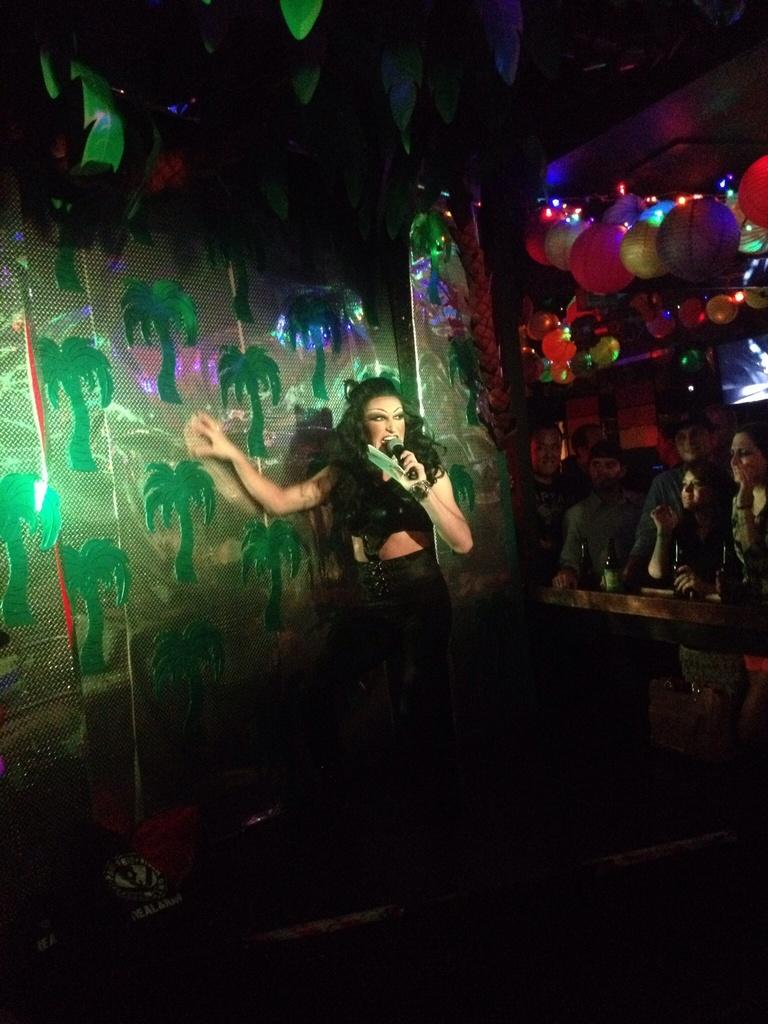What is the woman in the image holding? The woman is holding a mic and another object. Can you describe the group of people in the image? There is a group of people in the image, but their specific actions or characteristics are not mentioned in the facts. What type of objects can be seen in the image? Besides the mic and the unspecified object, there are bottles, balloons, lights, and leaves in the image. What is the setting of the image? The presence of leaves suggests that the image might be set in an outdoor or natural environment. What type of cake is being served at the event in the image? There is no cake present in the image, and no event is mentioned in the facts. 